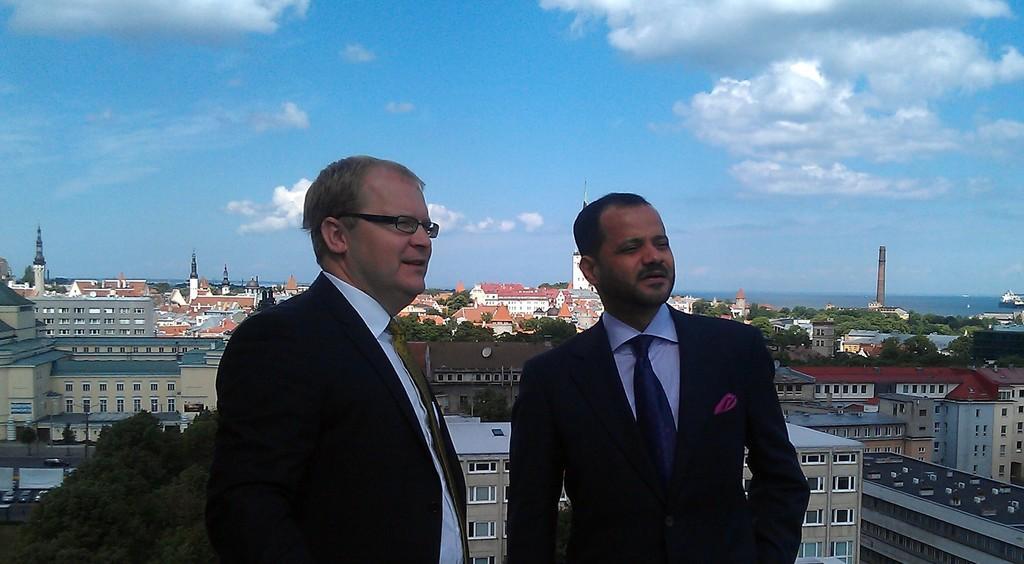Could you give a brief overview of what you see in this image? In the center of the image we can see two persons wearing the suits and standing. In the background we can see many buildings, trees, light poles, some towers and also the vehicles and road on the left. At the top we can see the sky with the clouds. 